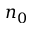Convert formula to latex. <formula><loc_0><loc_0><loc_500><loc_500>n _ { 0 }</formula> 